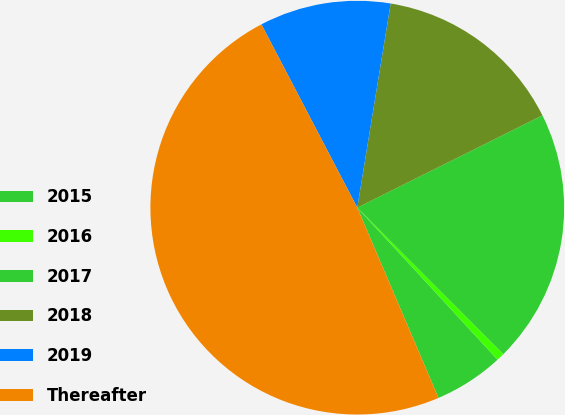Convert chart. <chart><loc_0><loc_0><loc_500><loc_500><pie_chart><fcel>2015<fcel>2016<fcel>2017<fcel>2018<fcel>2019<fcel>Thereafter<nl><fcel>5.44%<fcel>0.62%<fcel>19.88%<fcel>15.06%<fcel>10.25%<fcel>48.75%<nl></chart> 